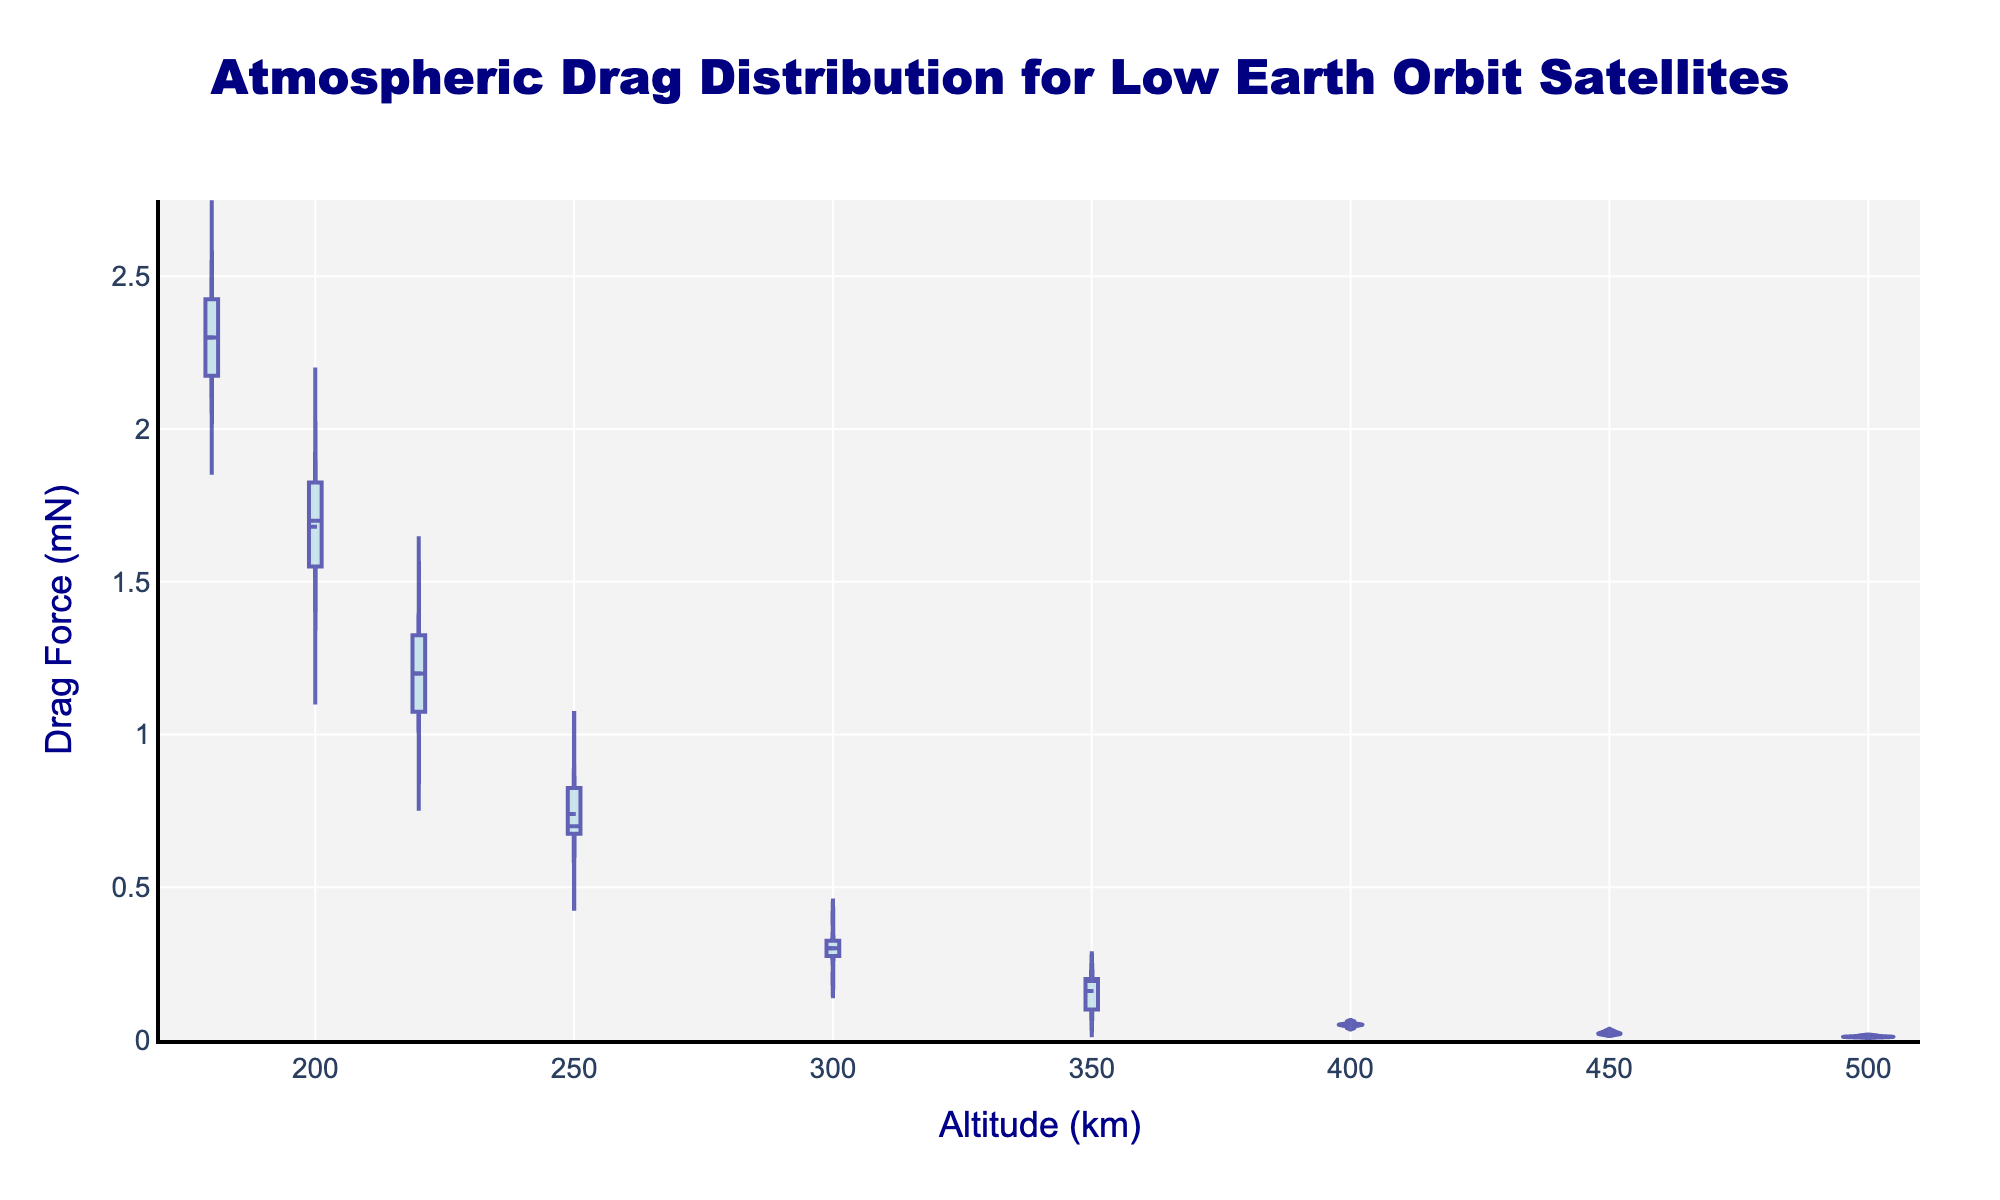What is the title of the figure? The title of the figure is displayed at the top center of the plot. It reads "Atmospheric Drag Distribution for Low Earth Orbit Satellites".
Answer: Atmospheric Drag Distribution for Low Earth Orbit Satellites What are the units used for the Drag Force? The y-axis label indicates that Drag Force is measured in milli-Newtons (mN).
Answer: milli-Newtons (mN) At which altitude does the maximum Drag Force occur? By examining the highest point on the y-axis, the maximum Drag Force of 2.5 mN occurs at an altitude of 180 km.
Answer: 180 km What is the general trend of Drag Force as altitude increases? Observing the distribution of the violins, Drag Force decreases as altitude increases.
Answer: Decreases What is the median Drag Force at an altitude of 220 km? For the altitude of 220 km, the median value is represented by the horizontal line within the box plot of the violin chart. This line is at 1.2 mN.
Answer: 1.2 mN How does the Drag Force distribution change between 180 km and 300 km in terms of interquartile range (IQR)? The IQR at 180 km is larger compared to 300 km, suggesting higher variability in Drag Force at lower altitudes. Specifically, the vertical range of the box inside the violin at 180 km is larger.
Answer: Larger at 180 km Which altitude has the smallest variance in Drag Force? The smallest variance can be inferred from the narrowest violin. At 350 km, the width of the violin is very narrow, indicating low variance.
Answer: 350 km Compare the mean Drag Force at 200 km and 250 km. Which one is higher? The mean Drag Force at each altitude is indicated by the white dot inside the violins. At 200 km, the mean is higher compared to 250 km, where the mean dot is lower.
Answer: 200 km At what altitude does the Drag Force have an outlier? There are no visible outliers, as no data points fall outside the whiskers of the box plots inside the violins.
Answer: No outliers 